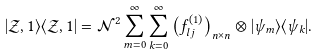<formula> <loc_0><loc_0><loc_500><loc_500>| \mathcal { Z } , 1 \rangle \langle \mathcal { Z } , 1 | = \mathcal { N } ^ { 2 } \sum _ { m = 0 } ^ { \infty } \sum _ { k = 0 } ^ { \infty } \left ( f _ { l j } ^ { ( 1 ) } \right ) _ { n \times n } \otimes | \psi _ { m } \rangle \langle \psi _ { k } | .</formula> 